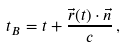Convert formula to latex. <formula><loc_0><loc_0><loc_500><loc_500>t _ { B } = t + \frac { \vec { r } ( t ) \cdot \vec { n } } { c } \, ,</formula> 